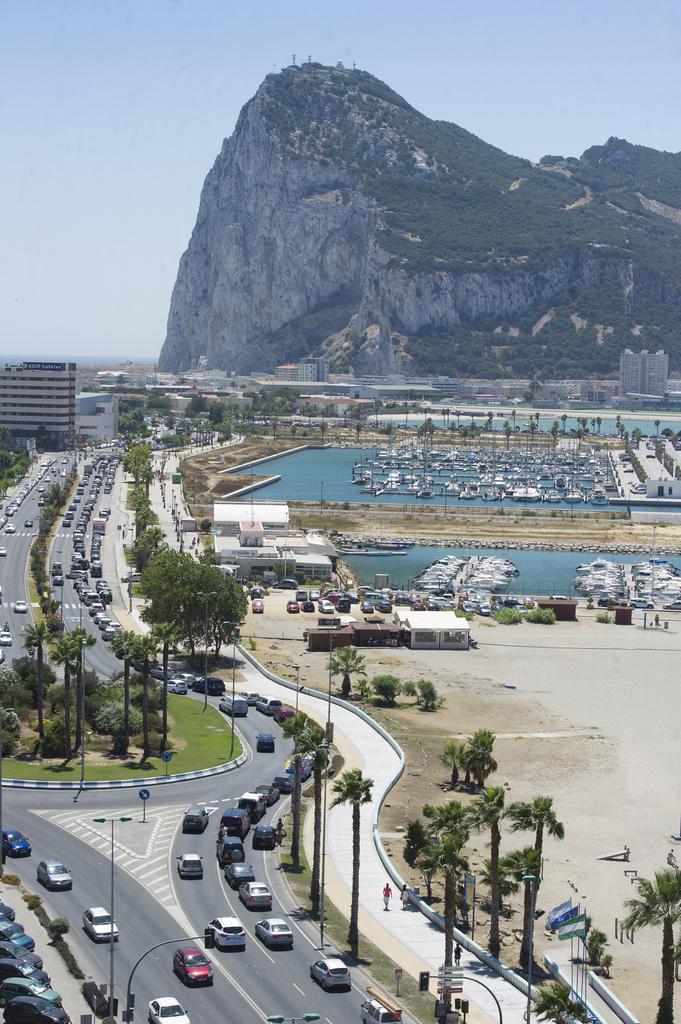In one or two sentences, can you explain what this image depicts? This is the top view of a city, in this image we can see cars passing on the road, there are trees, water, boats and buildings, in the background of the image there is a mountain. 